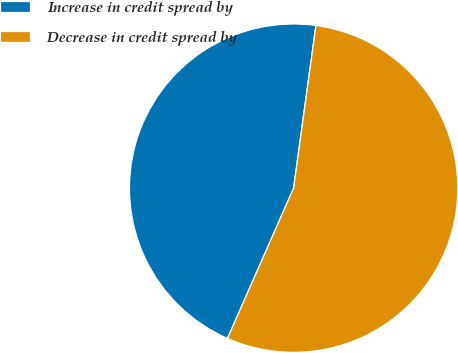<chart> <loc_0><loc_0><loc_500><loc_500><pie_chart><fcel>Increase in credit spread by<fcel>Decrease in credit spread by<nl><fcel>45.57%<fcel>54.43%<nl></chart> 